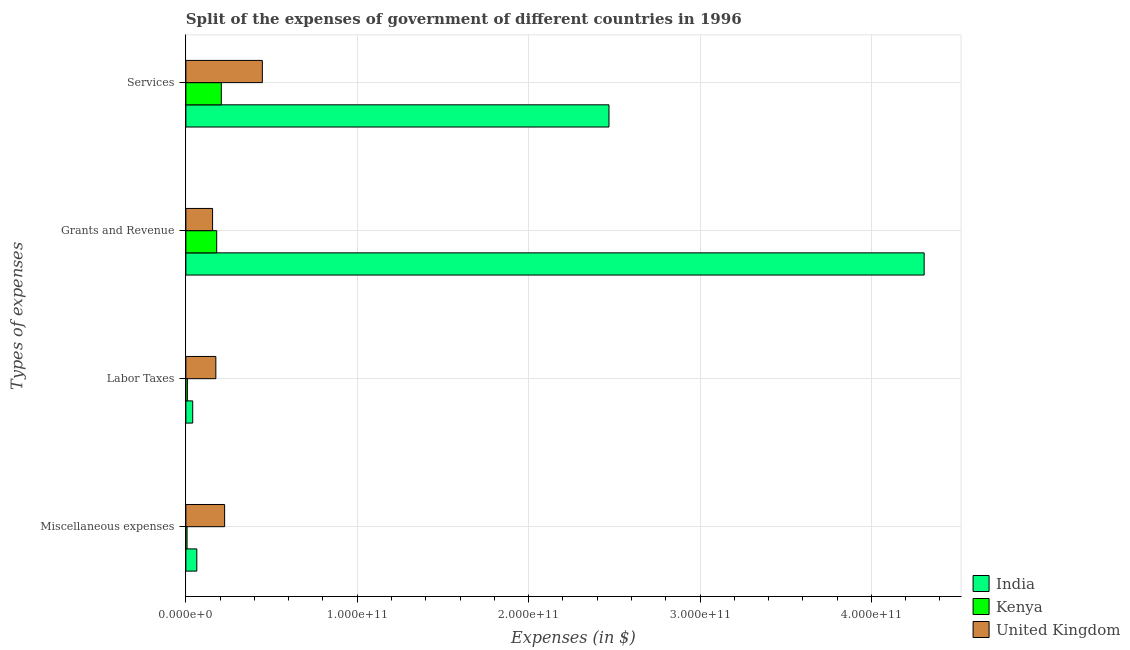How many groups of bars are there?
Give a very brief answer. 4. Are the number of bars per tick equal to the number of legend labels?
Your answer should be compact. Yes. How many bars are there on the 1st tick from the top?
Provide a succinct answer. 3. What is the label of the 2nd group of bars from the top?
Give a very brief answer. Grants and Revenue. What is the amount spent on miscellaneous expenses in United Kingdom?
Keep it short and to the point. 2.26e+1. Across all countries, what is the maximum amount spent on grants and revenue?
Your response must be concise. 4.31e+11. Across all countries, what is the minimum amount spent on services?
Give a very brief answer. 2.07e+1. What is the total amount spent on miscellaneous expenses in the graph?
Provide a succinct answer. 2.97e+1. What is the difference between the amount spent on labor taxes in Kenya and that in India?
Provide a short and direct response. -3.12e+09. What is the difference between the amount spent on grants and revenue in Kenya and the amount spent on miscellaneous expenses in United Kingdom?
Offer a terse response. -4.62e+09. What is the average amount spent on labor taxes per country?
Offer a terse response. 7.45e+09. What is the difference between the amount spent on miscellaneous expenses and amount spent on services in Kenya?
Your answer should be very brief. -2.00e+1. In how many countries, is the amount spent on grants and revenue greater than 160000000000 $?
Provide a short and direct response. 1. What is the ratio of the amount spent on labor taxes in Kenya to that in India?
Your response must be concise. 0.22. Is the amount spent on labor taxes in Kenya less than that in India?
Ensure brevity in your answer.  Yes. What is the difference between the highest and the second highest amount spent on labor taxes?
Your response must be concise. 1.35e+1. What is the difference between the highest and the lowest amount spent on labor taxes?
Give a very brief answer. 1.66e+1. In how many countries, is the amount spent on miscellaneous expenses greater than the average amount spent on miscellaneous expenses taken over all countries?
Your answer should be compact. 1. Is it the case that in every country, the sum of the amount spent on miscellaneous expenses and amount spent on grants and revenue is greater than the sum of amount spent on labor taxes and amount spent on services?
Ensure brevity in your answer.  No. What does the 2nd bar from the top in Labor Taxes represents?
Give a very brief answer. Kenya. What does the 3rd bar from the bottom in Miscellaneous expenses represents?
Provide a short and direct response. United Kingdom. How many bars are there?
Provide a succinct answer. 12. How many countries are there in the graph?
Give a very brief answer. 3. What is the difference between two consecutive major ticks on the X-axis?
Give a very brief answer. 1.00e+11. Are the values on the major ticks of X-axis written in scientific E-notation?
Your answer should be very brief. Yes. Does the graph contain any zero values?
Your answer should be very brief. No. How many legend labels are there?
Your answer should be very brief. 3. How are the legend labels stacked?
Provide a succinct answer. Vertical. What is the title of the graph?
Ensure brevity in your answer.  Split of the expenses of government of different countries in 1996. What is the label or title of the X-axis?
Your answer should be compact. Expenses (in $). What is the label or title of the Y-axis?
Your response must be concise. Types of expenses. What is the Expenses (in $) of India in Miscellaneous expenses?
Keep it short and to the point. 6.38e+09. What is the Expenses (in $) of Kenya in Miscellaneous expenses?
Ensure brevity in your answer.  6.88e+08. What is the Expenses (in $) in United Kingdom in Miscellaneous expenses?
Ensure brevity in your answer.  2.26e+1. What is the Expenses (in $) in India in Labor Taxes?
Provide a short and direct response. 3.99e+09. What is the Expenses (in $) of Kenya in Labor Taxes?
Provide a succinct answer. 8.73e+08. What is the Expenses (in $) in United Kingdom in Labor Taxes?
Your answer should be very brief. 1.75e+1. What is the Expenses (in $) in India in Grants and Revenue?
Your answer should be very brief. 4.31e+11. What is the Expenses (in $) of Kenya in Grants and Revenue?
Your answer should be compact. 1.80e+1. What is the Expenses (in $) of United Kingdom in Grants and Revenue?
Your answer should be very brief. 1.56e+1. What is the Expenses (in $) in India in Services?
Your answer should be compact. 2.47e+11. What is the Expenses (in $) in Kenya in Services?
Give a very brief answer. 2.07e+1. What is the Expenses (in $) in United Kingdom in Services?
Keep it short and to the point. 4.46e+1. Across all Types of expenses, what is the maximum Expenses (in $) in India?
Your response must be concise. 4.31e+11. Across all Types of expenses, what is the maximum Expenses (in $) in Kenya?
Keep it short and to the point. 2.07e+1. Across all Types of expenses, what is the maximum Expenses (in $) in United Kingdom?
Your response must be concise. 4.46e+1. Across all Types of expenses, what is the minimum Expenses (in $) of India?
Offer a terse response. 3.99e+09. Across all Types of expenses, what is the minimum Expenses (in $) in Kenya?
Ensure brevity in your answer.  6.88e+08. Across all Types of expenses, what is the minimum Expenses (in $) in United Kingdom?
Provide a succinct answer. 1.56e+1. What is the total Expenses (in $) of India in the graph?
Provide a succinct answer. 6.88e+11. What is the total Expenses (in $) of Kenya in the graph?
Offer a terse response. 4.02e+1. What is the total Expenses (in $) of United Kingdom in the graph?
Your response must be concise. 1.00e+11. What is the difference between the Expenses (in $) of India in Miscellaneous expenses and that in Labor Taxes?
Your answer should be very brief. 2.39e+09. What is the difference between the Expenses (in $) in Kenya in Miscellaneous expenses and that in Labor Taxes?
Give a very brief answer. -1.85e+08. What is the difference between the Expenses (in $) of United Kingdom in Miscellaneous expenses and that in Labor Taxes?
Make the answer very short. 5.13e+09. What is the difference between the Expenses (in $) in India in Miscellaneous expenses and that in Grants and Revenue?
Give a very brief answer. -4.24e+11. What is the difference between the Expenses (in $) of Kenya in Miscellaneous expenses and that in Grants and Revenue?
Your response must be concise. -1.73e+1. What is the difference between the Expenses (in $) in United Kingdom in Miscellaneous expenses and that in Grants and Revenue?
Provide a succinct answer. 7.02e+09. What is the difference between the Expenses (in $) of India in Miscellaneous expenses and that in Services?
Give a very brief answer. -2.41e+11. What is the difference between the Expenses (in $) of Kenya in Miscellaneous expenses and that in Services?
Offer a very short reply. -2.00e+1. What is the difference between the Expenses (in $) of United Kingdom in Miscellaneous expenses and that in Services?
Give a very brief answer. -2.20e+1. What is the difference between the Expenses (in $) in India in Labor Taxes and that in Grants and Revenue?
Make the answer very short. -4.27e+11. What is the difference between the Expenses (in $) in Kenya in Labor Taxes and that in Grants and Revenue?
Offer a terse response. -1.71e+1. What is the difference between the Expenses (in $) of United Kingdom in Labor Taxes and that in Grants and Revenue?
Make the answer very short. 1.90e+09. What is the difference between the Expenses (in $) in India in Labor Taxes and that in Services?
Provide a short and direct response. -2.43e+11. What is the difference between the Expenses (in $) in Kenya in Labor Taxes and that in Services?
Your answer should be compact. -1.98e+1. What is the difference between the Expenses (in $) of United Kingdom in Labor Taxes and that in Services?
Your answer should be compact. -2.71e+1. What is the difference between the Expenses (in $) in India in Grants and Revenue and that in Services?
Ensure brevity in your answer.  1.84e+11. What is the difference between the Expenses (in $) of Kenya in Grants and Revenue and that in Services?
Give a very brief answer. -2.70e+09. What is the difference between the Expenses (in $) of United Kingdom in Grants and Revenue and that in Services?
Offer a very short reply. -2.90e+1. What is the difference between the Expenses (in $) of India in Miscellaneous expenses and the Expenses (in $) of Kenya in Labor Taxes?
Provide a succinct answer. 5.51e+09. What is the difference between the Expenses (in $) of India in Miscellaneous expenses and the Expenses (in $) of United Kingdom in Labor Taxes?
Give a very brief answer. -1.11e+1. What is the difference between the Expenses (in $) of Kenya in Miscellaneous expenses and the Expenses (in $) of United Kingdom in Labor Taxes?
Make the answer very short. -1.68e+1. What is the difference between the Expenses (in $) of India in Miscellaneous expenses and the Expenses (in $) of Kenya in Grants and Revenue?
Provide a short and direct response. -1.16e+1. What is the difference between the Expenses (in $) of India in Miscellaneous expenses and the Expenses (in $) of United Kingdom in Grants and Revenue?
Your answer should be compact. -9.20e+09. What is the difference between the Expenses (in $) of Kenya in Miscellaneous expenses and the Expenses (in $) of United Kingdom in Grants and Revenue?
Your response must be concise. -1.49e+1. What is the difference between the Expenses (in $) of India in Miscellaneous expenses and the Expenses (in $) of Kenya in Services?
Give a very brief answer. -1.43e+1. What is the difference between the Expenses (in $) in India in Miscellaneous expenses and the Expenses (in $) in United Kingdom in Services?
Provide a succinct answer. -3.82e+1. What is the difference between the Expenses (in $) in Kenya in Miscellaneous expenses and the Expenses (in $) in United Kingdom in Services?
Offer a very short reply. -4.39e+1. What is the difference between the Expenses (in $) of India in Labor Taxes and the Expenses (in $) of Kenya in Grants and Revenue?
Keep it short and to the point. -1.40e+1. What is the difference between the Expenses (in $) of India in Labor Taxes and the Expenses (in $) of United Kingdom in Grants and Revenue?
Your answer should be very brief. -1.16e+1. What is the difference between the Expenses (in $) of Kenya in Labor Taxes and the Expenses (in $) of United Kingdom in Grants and Revenue?
Keep it short and to the point. -1.47e+1. What is the difference between the Expenses (in $) in India in Labor Taxes and the Expenses (in $) in Kenya in Services?
Ensure brevity in your answer.  -1.67e+1. What is the difference between the Expenses (in $) in India in Labor Taxes and the Expenses (in $) in United Kingdom in Services?
Your answer should be very brief. -4.06e+1. What is the difference between the Expenses (in $) in Kenya in Labor Taxes and the Expenses (in $) in United Kingdom in Services?
Give a very brief answer. -4.38e+1. What is the difference between the Expenses (in $) of India in Grants and Revenue and the Expenses (in $) of Kenya in Services?
Your answer should be compact. 4.10e+11. What is the difference between the Expenses (in $) of India in Grants and Revenue and the Expenses (in $) of United Kingdom in Services?
Your answer should be very brief. 3.86e+11. What is the difference between the Expenses (in $) of Kenya in Grants and Revenue and the Expenses (in $) of United Kingdom in Services?
Provide a succinct answer. -2.66e+1. What is the average Expenses (in $) in India per Types of expenses?
Keep it short and to the point. 1.72e+11. What is the average Expenses (in $) of Kenya per Types of expenses?
Offer a terse response. 1.01e+1. What is the average Expenses (in $) in United Kingdom per Types of expenses?
Provide a succinct answer. 2.51e+1. What is the difference between the Expenses (in $) in India and Expenses (in $) in Kenya in Miscellaneous expenses?
Provide a succinct answer. 5.69e+09. What is the difference between the Expenses (in $) of India and Expenses (in $) of United Kingdom in Miscellaneous expenses?
Offer a terse response. -1.62e+1. What is the difference between the Expenses (in $) in Kenya and Expenses (in $) in United Kingdom in Miscellaneous expenses?
Keep it short and to the point. -2.19e+1. What is the difference between the Expenses (in $) in India and Expenses (in $) in Kenya in Labor Taxes?
Ensure brevity in your answer.  3.12e+09. What is the difference between the Expenses (in $) in India and Expenses (in $) in United Kingdom in Labor Taxes?
Your answer should be very brief. -1.35e+1. What is the difference between the Expenses (in $) of Kenya and Expenses (in $) of United Kingdom in Labor Taxes?
Provide a succinct answer. -1.66e+1. What is the difference between the Expenses (in $) in India and Expenses (in $) in Kenya in Grants and Revenue?
Ensure brevity in your answer.  4.13e+11. What is the difference between the Expenses (in $) in India and Expenses (in $) in United Kingdom in Grants and Revenue?
Offer a terse response. 4.15e+11. What is the difference between the Expenses (in $) in Kenya and Expenses (in $) in United Kingdom in Grants and Revenue?
Ensure brevity in your answer.  2.41e+09. What is the difference between the Expenses (in $) in India and Expenses (in $) in Kenya in Services?
Provide a short and direct response. 2.26e+11. What is the difference between the Expenses (in $) in India and Expenses (in $) in United Kingdom in Services?
Your answer should be very brief. 2.02e+11. What is the difference between the Expenses (in $) in Kenya and Expenses (in $) in United Kingdom in Services?
Provide a succinct answer. -2.39e+1. What is the ratio of the Expenses (in $) of India in Miscellaneous expenses to that in Labor Taxes?
Ensure brevity in your answer.  1.6. What is the ratio of the Expenses (in $) of Kenya in Miscellaneous expenses to that in Labor Taxes?
Make the answer very short. 0.79. What is the ratio of the Expenses (in $) in United Kingdom in Miscellaneous expenses to that in Labor Taxes?
Your answer should be compact. 1.29. What is the ratio of the Expenses (in $) of India in Miscellaneous expenses to that in Grants and Revenue?
Provide a short and direct response. 0.01. What is the ratio of the Expenses (in $) in Kenya in Miscellaneous expenses to that in Grants and Revenue?
Make the answer very short. 0.04. What is the ratio of the Expenses (in $) in United Kingdom in Miscellaneous expenses to that in Grants and Revenue?
Your answer should be compact. 1.45. What is the ratio of the Expenses (in $) in India in Miscellaneous expenses to that in Services?
Provide a short and direct response. 0.03. What is the ratio of the Expenses (in $) of United Kingdom in Miscellaneous expenses to that in Services?
Make the answer very short. 0.51. What is the ratio of the Expenses (in $) in India in Labor Taxes to that in Grants and Revenue?
Keep it short and to the point. 0.01. What is the ratio of the Expenses (in $) in Kenya in Labor Taxes to that in Grants and Revenue?
Your response must be concise. 0.05. What is the ratio of the Expenses (in $) in United Kingdom in Labor Taxes to that in Grants and Revenue?
Keep it short and to the point. 1.12. What is the ratio of the Expenses (in $) of India in Labor Taxes to that in Services?
Your response must be concise. 0.02. What is the ratio of the Expenses (in $) of Kenya in Labor Taxes to that in Services?
Your response must be concise. 0.04. What is the ratio of the Expenses (in $) in United Kingdom in Labor Taxes to that in Services?
Your response must be concise. 0.39. What is the ratio of the Expenses (in $) in India in Grants and Revenue to that in Services?
Provide a succinct answer. 1.74. What is the ratio of the Expenses (in $) of Kenya in Grants and Revenue to that in Services?
Give a very brief answer. 0.87. What is the ratio of the Expenses (in $) of United Kingdom in Grants and Revenue to that in Services?
Your response must be concise. 0.35. What is the difference between the highest and the second highest Expenses (in $) of India?
Your response must be concise. 1.84e+11. What is the difference between the highest and the second highest Expenses (in $) of Kenya?
Your response must be concise. 2.70e+09. What is the difference between the highest and the second highest Expenses (in $) in United Kingdom?
Provide a short and direct response. 2.20e+1. What is the difference between the highest and the lowest Expenses (in $) in India?
Provide a short and direct response. 4.27e+11. What is the difference between the highest and the lowest Expenses (in $) in Kenya?
Your answer should be very brief. 2.00e+1. What is the difference between the highest and the lowest Expenses (in $) in United Kingdom?
Give a very brief answer. 2.90e+1. 